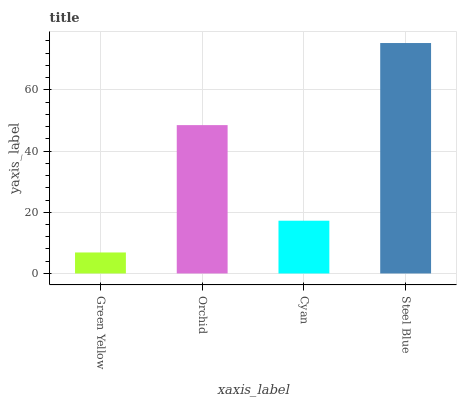Is Orchid the minimum?
Answer yes or no. No. Is Orchid the maximum?
Answer yes or no. No. Is Orchid greater than Green Yellow?
Answer yes or no. Yes. Is Green Yellow less than Orchid?
Answer yes or no. Yes. Is Green Yellow greater than Orchid?
Answer yes or no. No. Is Orchid less than Green Yellow?
Answer yes or no. No. Is Orchid the high median?
Answer yes or no. Yes. Is Cyan the low median?
Answer yes or no. Yes. Is Green Yellow the high median?
Answer yes or no. No. Is Orchid the low median?
Answer yes or no. No. 